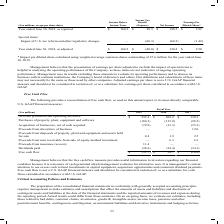According to Carpenter Technology's financial document, What was the Proceeds from insurance recovery in 2019? According to the financial document, 11.4 (in millions). The relevant text states: "stment — 6.3 6.3 Proceeds from insurance recovery 11.4 — — Dividends paid (38.6) (34.4) (34.1) Free cash flow $ (53.7) $ 34.7 $ (16.8)..." Also, What does management believe the free cash flow measure provides? useful information to investors regarding our financial condition because it is a measure of cash generated which management evaluates for alternative uses. The document states: "believes that the free cash flow measure provides useful information to investors regarding our financial condition because it is a measure of cash ge..." Also, In which years was free cash flow calculated? The document contains multiple relevant values: 2019, 2018, 2017. From the document: "($ in millions) 2019 2018 2017 Net cash provided from operating activities $ 232.4 $ 209.2 $ 130.3 Purchases of property, plant, e ($ in millions) 201..." Additionally, In which year was the Proceeds from disposals of property, plant and equipment and assets held for sale largest? According to the financial document, 2017. The relevant text states: "($ in millions) 2019 2018 2017 Net cash provided from operating activities $ 232.4 $ 209.2 $ 130.3 Purchases of property, plant, e..." Also, can you calculate: What was the change in Net cash provided from operating activities in 2019 from 2018? Based on the calculation: 232.4-209.2, the result is 23.2 (in millions). This is based on the information: "cash provided from operating activities $ 232.4 $ 209.2 $ 130.3 Purchases of property, plant, equipment and software (180.3) (135.0) (98.5) Acquisition of 017 Net cash provided from operating activiti..." The key data points involved are: 209.2, 232.4. Also, can you calculate: What was the percentage change in Net cash provided from operating activities in 2019 from 2018? To answer this question, I need to perform calculations using the financial data. The calculation is: (232.4-209.2)/209.2, which equals 11.09 (percentage). This is based on the information: "cash provided from operating activities $ 232.4 $ 209.2 $ 130.3 Purchases of property, plant, equipment and software (180.3) (135.0) (98.5) Acquisition of 017 Net cash provided from operating activiti..." The key data points involved are: 209.2, 232.4. 